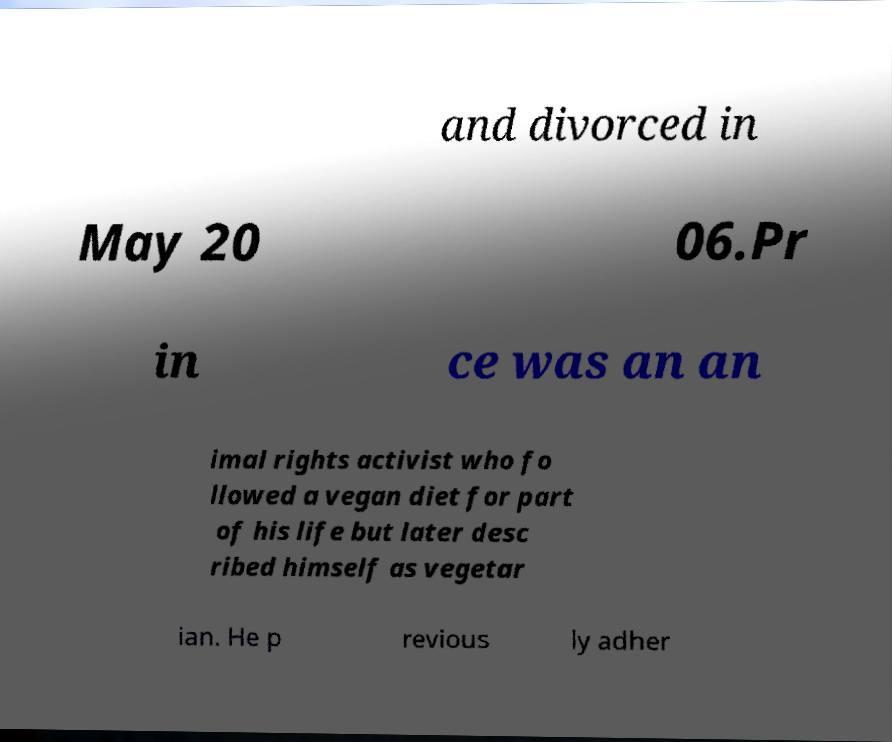Please read and relay the text visible in this image. What does it say? and divorced in May 20 06.Pr in ce was an an imal rights activist who fo llowed a vegan diet for part of his life but later desc ribed himself as vegetar ian. He p revious ly adher 